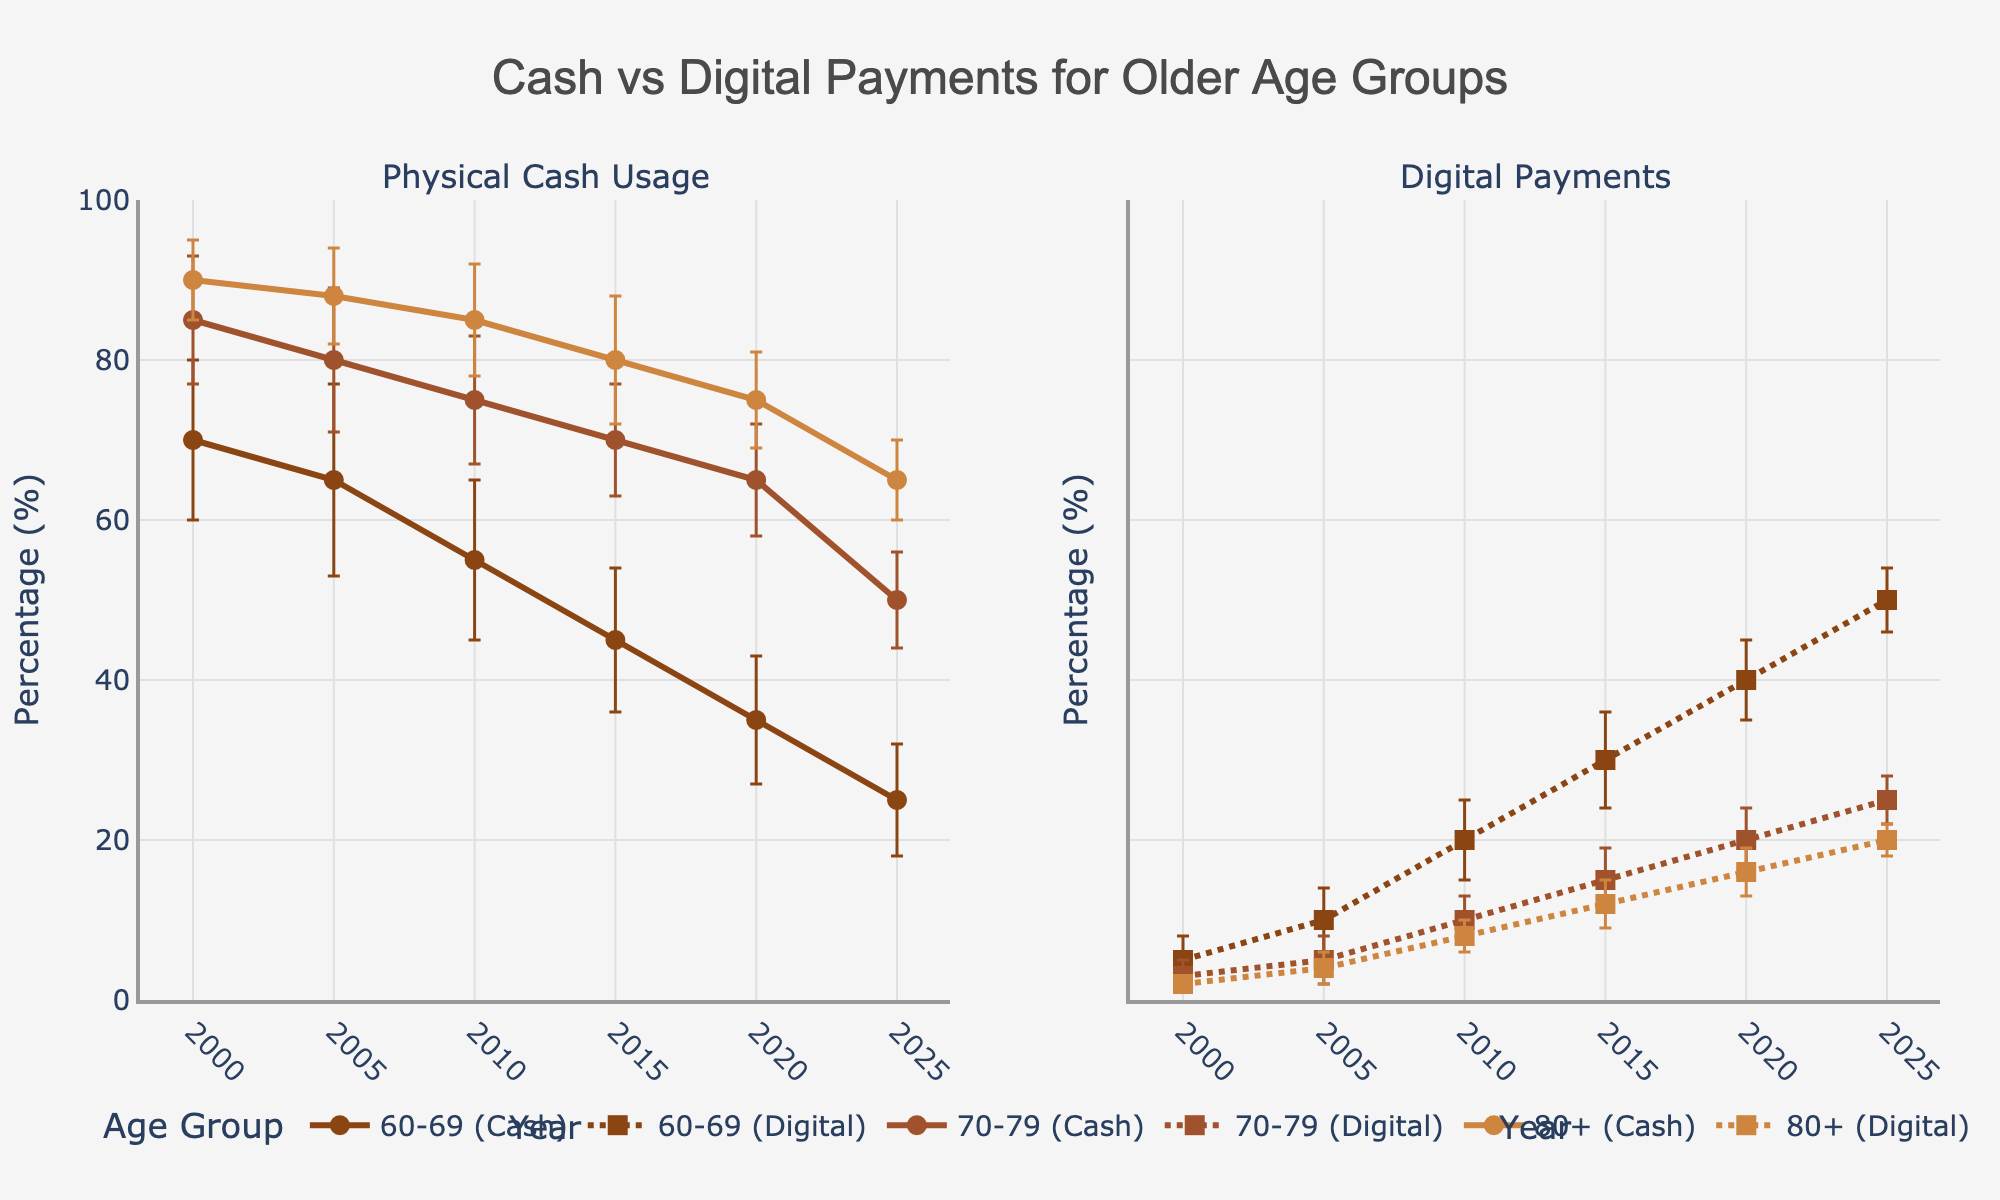What is the title of the figure? The title of the figure is located at the top center. It reads "Cash vs Digital Payments for Older Age Groups."
Answer: Cash vs Digital Payments for Older Age Groups What do the x-axes and y-axes represent in this figure? The x-axes represent the "Year" from 2000 to 2025, while the y-axes represent the "Percentage (%)" of either physical cash usage or digital payments.
Answer: Year; Percentage (%) How does physical cash usage change for the age group 60-69 from 2000 to 2025? Observing the left sub-plot (Physical Cash Usage), the cash usage for the 60-69 age group decreases from around 70% in 2000 to about 25% in 2025.
Answer: Decreases from 70% to 25% Between which years did the 70-79 age group see the largest drop in physical cash usage? Comparing the slopes in the left sub-plot for 70-79, the largest drop is observed between 2015 and 2025, from around 70% to 50%.
Answer: 2015 to 2025 How did digital payments change for the age group 80+ from 2000 to 2025? Observing the right sub-plot (Digital Payments), the digital payments for the 80+ age group increased from around 2% in 2000 to 20% in 2025.
Answer: Increased from 2% to 20% Which age group had the highest physical cash usage in 2020? Referring to the left sub-plot at the year 2020, the age group 80+ had the highest physical cash usage at around 75%.
Answer: 80+ In 2015, which age group had a larger proportion of digital payments than physical cash usage? Examining the 2015 data in both sub-plots, the 60-69 age group had 45% physical cash usage and 30% digital payments, hence none had larger digital payments than cash usage.
Answer: None Compare the error bars for digital payments across the age groups in 2020. Which group has the largest error? Observing the error bars on the right sub-plot for 2020, the 60-69 group has the largest error bar, indicating more uncertainty.
Answer: 60-69 Calculate the average physical cash usage for the 70-79 age group from 2000 to 2025. Sum the percentages for 70-79 across the years (85 + 80 + 75 + 70 + 65 + 50) = 425. Divide by the number of years (6). 425/6 ≈ 70.83.
Answer: 70.83% Which age group showed the most consistent digital payments usage trend from 2000 to 2025? Observing the slopes and the error bars in the right sub-plot, the 70-79 age group trends moderately upwards without large fluctuations or significant error bars.
Answer: 70-79 